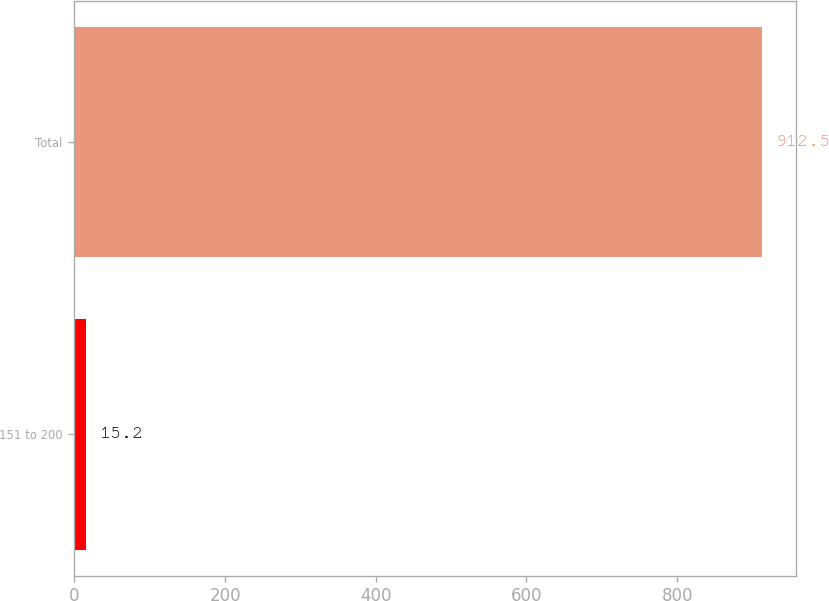Convert chart to OTSL. <chart><loc_0><loc_0><loc_500><loc_500><bar_chart><fcel>151 to 200<fcel>Total<nl><fcel>15.2<fcel>912.5<nl></chart> 